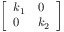Convert formula to latex. <formula><loc_0><loc_0><loc_500><loc_500>\left [ \begin{array} { l l } { k _ { 1 } } & { 0 } \\ { 0 } & { k _ { 2 } } \end{array} \right ]</formula> 